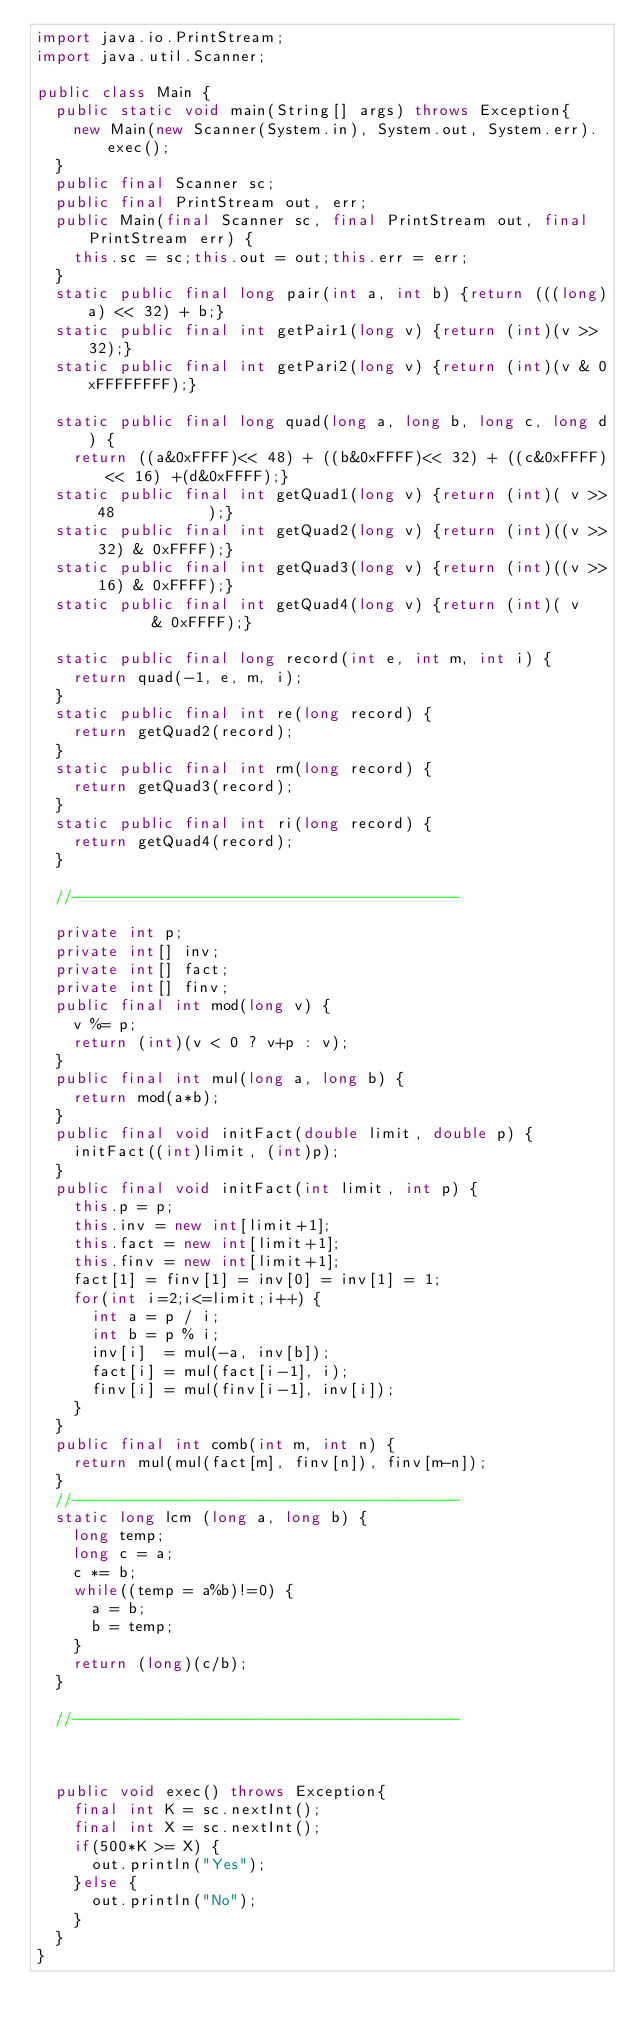<code> <loc_0><loc_0><loc_500><loc_500><_Java_>import java.io.PrintStream;
import java.util.Scanner;

public class Main {
	public static void main(String[] args) throws Exception{
		new Main(new Scanner(System.in), System.out, System.err).exec();
	}
	public final Scanner sc;
	public final PrintStream out, err;
	public Main(final Scanner sc, final PrintStream out, final PrintStream err) {
		this.sc = sc;this.out = out;this.err = err;
	}
	static public final long pair(int a, int b) {return (((long)a) << 32) + b;}
	static public final int getPair1(long v) {return (int)(v >> 32);}
	static public final int getPari2(long v) {return (int)(v & 0xFFFFFFFF);}

	static public final long quad(long a, long b, long c, long d) {
		return ((a&0xFFFF)<< 48) + ((b&0xFFFF)<< 32) + ((c&0xFFFF)<< 16) +(d&0xFFFF);}
	static public final int getQuad1(long v) {return (int)( v >> 48          );}
	static public final int getQuad2(long v) {return (int)((v >> 32) & 0xFFFF);}
	static public final int getQuad3(long v) {return (int)((v >> 16) & 0xFFFF);}
	static public final int getQuad4(long v) {return (int)( v        & 0xFFFF);}

	static public final long record(int e, int m, int i) {
		return quad(-1, e, m, i);
	}
	static public final int re(long record) {
		return getQuad2(record);
	}
	static public final int rm(long record) {
		return getQuad3(record);
	}
	static public final int ri(long record) {
		return getQuad4(record);
	}

	//------------------------------------------

	private int p;
	private int[] inv;
	private int[] fact;
	private int[] finv;
	public final int mod(long v) {
		v %= p;
		return (int)(v < 0 ? v+p : v);
	}
	public final int mul(long a, long b) {
		return mod(a*b);
	}
	public final void initFact(double limit, double p) {
		initFact((int)limit, (int)p);
	}
	public final void initFact(int limit, int p) {
		this.p = p;
		this.inv = new int[limit+1];
		this.fact = new int[limit+1];
		this.finv = new int[limit+1];
		fact[1] = finv[1] = inv[0] = inv[1] = 1;
		for(int i=2;i<=limit;i++) {
			int a = p / i;
			int b = p % i;
			inv[i]  = mul(-a, inv[b]);
			fact[i] = mul(fact[i-1], i);
			finv[i] = mul(finv[i-1], inv[i]);
		}
	}
	public final int comb(int m, int n) {
		return mul(mul(fact[m], finv[n]), finv[m-n]);
	}
	//------------------------------------------
	static long lcm (long a, long b) {
		long temp;
		long c = a;
		c *= b;
		while((temp = a%b)!=0) {
			a = b;
			b = temp;
		}
		return (long)(c/b);
	}

	//------------------------------------------



	public void exec() throws Exception{
		final int K = sc.nextInt();
		final int X = sc.nextInt();
		if(500*K >= X) {
			out.println("Yes");
		}else {
			out.println("No");
		}
	}
}
</code> 